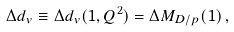<formula> <loc_0><loc_0><loc_500><loc_500>\Delta d _ { v } \equiv \Delta { d _ { v } } ( 1 , Q ^ { 2 } ) = \Delta M _ { D / p } ( 1 ) \, ,</formula> 